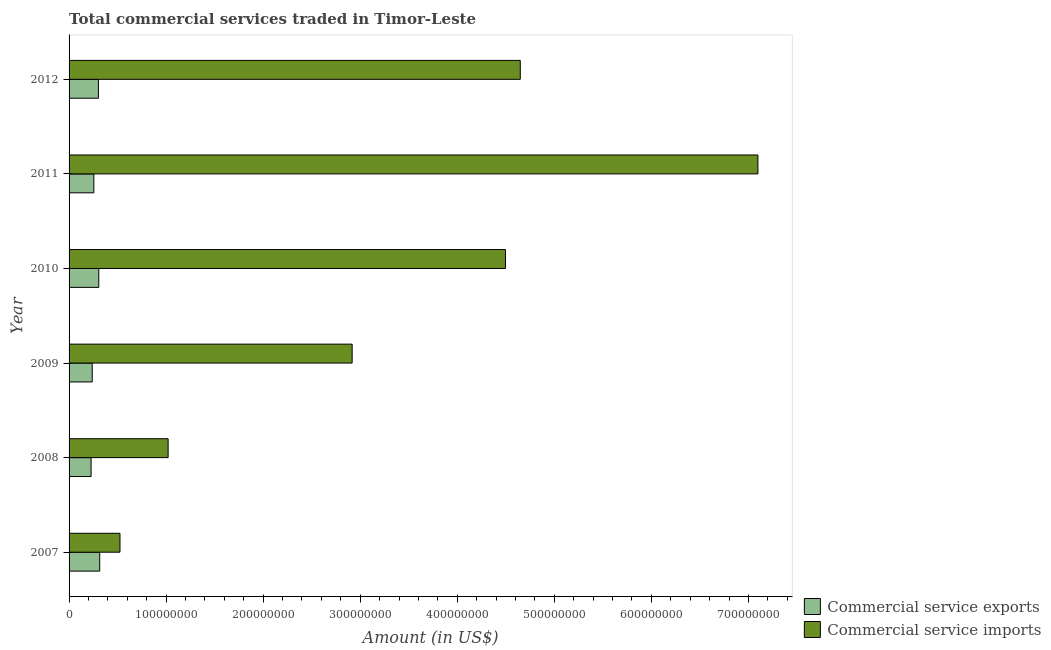How many groups of bars are there?
Ensure brevity in your answer.  6. Are the number of bars per tick equal to the number of legend labels?
Provide a short and direct response. Yes. Are the number of bars on each tick of the Y-axis equal?
Offer a very short reply. Yes. How many bars are there on the 5th tick from the bottom?
Make the answer very short. 2. What is the label of the 1st group of bars from the top?
Make the answer very short. 2012. What is the amount of commercial service imports in 2011?
Your response must be concise. 7.10e+08. Across all years, what is the maximum amount of commercial service imports?
Keep it short and to the point. 7.10e+08. Across all years, what is the minimum amount of commercial service imports?
Make the answer very short. 5.24e+07. What is the total amount of commercial service imports in the graph?
Offer a very short reply. 2.07e+09. What is the difference between the amount of commercial service imports in 2009 and that in 2011?
Provide a short and direct response. -4.18e+08. What is the difference between the amount of commercial service imports in 2009 and the amount of commercial service exports in 2012?
Your answer should be compact. 2.61e+08. What is the average amount of commercial service imports per year?
Provide a succinct answer. 3.45e+08. In the year 2007, what is the difference between the amount of commercial service exports and amount of commercial service imports?
Your answer should be compact. -2.09e+07. What is the ratio of the amount of commercial service exports in 2007 to that in 2008?
Offer a terse response. 1.39. Is the amount of commercial service imports in 2007 less than that in 2009?
Your answer should be very brief. Yes. Is the difference between the amount of commercial service exports in 2009 and 2011 greater than the difference between the amount of commercial service imports in 2009 and 2011?
Offer a terse response. Yes. What is the difference between the highest and the second highest amount of commercial service exports?
Keep it short and to the point. 9.52e+05. What is the difference between the highest and the lowest amount of commercial service imports?
Make the answer very short. 6.57e+08. What does the 2nd bar from the top in 2008 represents?
Your response must be concise. Commercial service exports. What does the 1st bar from the bottom in 2008 represents?
Keep it short and to the point. Commercial service exports. Does the graph contain any zero values?
Give a very brief answer. No. Does the graph contain grids?
Give a very brief answer. No. How are the legend labels stacked?
Keep it short and to the point. Vertical. What is the title of the graph?
Your answer should be very brief. Total commercial services traded in Timor-Leste. What is the label or title of the X-axis?
Your response must be concise. Amount (in US$). What is the Amount (in US$) of Commercial service exports in 2007?
Provide a short and direct response. 3.16e+07. What is the Amount (in US$) of Commercial service imports in 2007?
Give a very brief answer. 5.24e+07. What is the Amount (in US$) of Commercial service exports in 2008?
Offer a terse response. 2.27e+07. What is the Amount (in US$) in Commercial service imports in 2008?
Ensure brevity in your answer.  1.02e+08. What is the Amount (in US$) in Commercial service exports in 2009?
Ensure brevity in your answer.  2.38e+07. What is the Amount (in US$) in Commercial service imports in 2009?
Your response must be concise. 2.92e+08. What is the Amount (in US$) of Commercial service exports in 2010?
Provide a succinct answer. 3.06e+07. What is the Amount (in US$) of Commercial service imports in 2010?
Provide a succinct answer. 4.50e+08. What is the Amount (in US$) of Commercial service exports in 2011?
Your response must be concise. 2.55e+07. What is the Amount (in US$) in Commercial service imports in 2011?
Ensure brevity in your answer.  7.10e+08. What is the Amount (in US$) of Commercial service exports in 2012?
Make the answer very short. 3.02e+07. What is the Amount (in US$) of Commercial service imports in 2012?
Give a very brief answer. 4.65e+08. Across all years, what is the maximum Amount (in US$) in Commercial service exports?
Your response must be concise. 3.16e+07. Across all years, what is the maximum Amount (in US$) of Commercial service imports?
Your answer should be very brief. 7.10e+08. Across all years, what is the minimum Amount (in US$) of Commercial service exports?
Offer a very short reply. 2.27e+07. Across all years, what is the minimum Amount (in US$) in Commercial service imports?
Keep it short and to the point. 5.24e+07. What is the total Amount (in US$) in Commercial service exports in the graph?
Make the answer very short. 1.64e+08. What is the total Amount (in US$) of Commercial service imports in the graph?
Your answer should be compact. 2.07e+09. What is the difference between the Amount (in US$) of Commercial service exports in 2007 and that in 2008?
Provide a succinct answer. 8.88e+06. What is the difference between the Amount (in US$) of Commercial service imports in 2007 and that in 2008?
Ensure brevity in your answer.  -4.96e+07. What is the difference between the Amount (in US$) in Commercial service exports in 2007 and that in 2009?
Give a very brief answer. 7.71e+06. What is the difference between the Amount (in US$) in Commercial service imports in 2007 and that in 2009?
Provide a short and direct response. -2.39e+08. What is the difference between the Amount (in US$) of Commercial service exports in 2007 and that in 2010?
Keep it short and to the point. 9.52e+05. What is the difference between the Amount (in US$) of Commercial service imports in 2007 and that in 2010?
Offer a very short reply. -3.97e+08. What is the difference between the Amount (in US$) in Commercial service exports in 2007 and that in 2011?
Your response must be concise. 6.04e+06. What is the difference between the Amount (in US$) in Commercial service imports in 2007 and that in 2011?
Give a very brief answer. -6.57e+08. What is the difference between the Amount (in US$) of Commercial service exports in 2007 and that in 2012?
Offer a very short reply. 1.31e+06. What is the difference between the Amount (in US$) of Commercial service imports in 2007 and that in 2012?
Your answer should be very brief. -4.12e+08. What is the difference between the Amount (in US$) of Commercial service exports in 2008 and that in 2009?
Provide a succinct answer. -1.17e+06. What is the difference between the Amount (in US$) of Commercial service imports in 2008 and that in 2009?
Your answer should be very brief. -1.90e+08. What is the difference between the Amount (in US$) in Commercial service exports in 2008 and that in 2010?
Give a very brief answer. -7.93e+06. What is the difference between the Amount (in US$) of Commercial service imports in 2008 and that in 2010?
Ensure brevity in your answer.  -3.48e+08. What is the difference between the Amount (in US$) of Commercial service exports in 2008 and that in 2011?
Offer a very short reply. -2.85e+06. What is the difference between the Amount (in US$) in Commercial service imports in 2008 and that in 2011?
Ensure brevity in your answer.  -6.08e+08. What is the difference between the Amount (in US$) of Commercial service exports in 2008 and that in 2012?
Give a very brief answer. -7.57e+06. What is the difference between the Amount (in US$) of Commercial service imports in 2008 and that in 2012?
Give a very brief answer. -3.63e+08. What is the difference between the Amount (in US$) of Commercial service exports in 2009 and that in 2010?
Make the answer very short. -6.76e+06. What is the difference between the Amount (in US$) in Commercial service imports in 2009 and that in 2010?
Offer a very short reply. -1.58e+08. What is the difference between the Amount (in US$) in Commercial service exports in 2009 and that in 2011?
Make the answer very short. -1.67e+06. What is the difference between the Amount (in US$) of Commercial service imports in 2009 and that in 2011?
Give a very brief answer. -4.18e+08. What is the difference between the Amount (in US$) of Commercial service exports in 2009 and that in 2012?
Provide a short and direct response. -6.40e+06. What is the difference between the Amount (in US$) in Commercial service imports in 2009 and that in 2012?
Your answer should be compact. -1.73e+08. What is the difference between the Amount (in US$) of Commercial service exports in 2010 and that in 2011?
Provide a succinct answer. 5.08e+06. What is the difference between the Amount (in US$) in Commercial service imports in 2010 and that in 2011?
Offer a terse response. -2.60e+08. What is the difference between the Amount (in US$) in Commercial service exports in 2010 and that in 2012?
Give a very brief answer. 3.61e+05. What is the difference between the Amount (in US$) in Commercial service imports in 2010 and that in 2012?
Ensure brevity in your answer.  -1.53e+07. What is the difference between the Amount (in US$) of Commercial service exports in 2011 and that in 2012?
Provide a short and direct response. -4.72e+06. What is the difference between the Amount (in US$) in Commercial service imports in 2011 and that in 2012?
Provide a short and direct response. 2.45e+08. What is the difference between the Amount (in US$) in Commercial service exports in 2007 and the Amount (in US$) in Commercial service imports in 2008?
Offer a very short reply. -7.05e+07. What is the difference between the Amount (in US$) in Commercial service exports in 2007 and the Amount (in US$) in Commercial service imports in 2009?
Make the answer very short. -2.60e+08. What is the difference between the Amount (in US$) of Commercial service exports in 2007 and the Amount (in US$) of Commercial service imports in 2010?
Keep it short and to the point. -4.18e+08. What is the difference between the Amount (in US$) in Commercial service exports in 2007 and the Amount (in US$) in Commercial service imports in 2011?
Your answer should be compact. -6.78e+08. What is the difference between the Amount (in US$) of Commercial service exports in 2007 and the Amount (in US$) of Commercial service imports in 2012?
Provide a short and direct response. -4.33e+08. What is the difference between the Amount (in US$) in Commercial service exports in 2008 and the Amount (in US$) in Commercial service imports in 2009?
Ensure brevity in your answer.  -2.69e+08. What is the difference between the Amount (in US$) in Commercial service exports in 2008 and the Amount (in US$) in Commercial service imports in 2010?
Make the answer very short. -4.27e+08. What is the difference between the Amount (in US$) of Commercial service exports in 2008 and the Amount (in US$) of Commercial service imports in 2011?
Your answer should be compact. -6.87e+08. What is the difference between the Amount (in US$) in Commercial service exports in 2008 and the Amount (in US$) in Commercial service imports in 2012?
Keep it short and to the point. -4.42e+08. What is the difference between the Amount (in US$) in Commercial service exports in 2009 and the Amount (in US$) in Commercial service imports in 2010?
Offer a very short reply. -4.26e+08. What is the difference between the Amount (in US$) of Commercial service exports in 2009 and the Amount (in US$) of Commercial service imports in 2011?
Your answer should be compact. -6.86e+08. What is the difference between the Amount (in US$) of Commercial service exports in 2009 and the Amount (in US$) of Commercial service imports in 2012?
Make the answer very short. -4.41e+08. What is the difference between the Amount (in US$) of Commercial service exports in 2010 and the Amount (in US$) of Commercial service imports in 2011?
Your response must be concise. -6.79e+08. What is the difference between the Amount (in US$) of Commercial service exports in 2010 and the Amount (in US$) of Commercial service imports in 2012?
Offer a terse response. -4.34e+08. What is the difference between the Amount (in US$) of Commercial service exports in 2011 and the Amount (in US$) of Commercial service imports in 2012?
Give a very brief answer. -4.39e+08. What is the average Amount (in US$) of Commercial service exports per year?
Your answer should be very brief. 2.74e+07. What is the average Amount (in US$) in Commercial service imports per year?
Offer a very short reply. 3.45e+08. In the year 2007, what is the difference between the Amount (in US$) of Commercial service exports and Amount (in US$) of Commercial service imports?
Keep it short and to the point. -2.09e+07. In the year 2008, what is the difference between the Amount (in US$) of Commercial service exports and Amount (in US$) of Commercial service imports?
Your answer should be compact. -7.94e+07. In the year 2009, what is the difference between the Amount (in US$) in Commercial service exports and Amount (in US$) in Commercial service imports?
Make the answer very short. -2.68e+08. In the year 2010, what is the difference between the Amount (in US$) of Commercial service exports and Amount (in US$) of Commercial service imports?
Your answer should be very brief. -4.19e+08. In the year 2011, what is the difference between the Amount (in US$) of Commercial service exports and Amount (in US$) of Commercial service imports?
Ensure brevity in your answer.  -6.84e+08. In the year 2012, what is the difference between the Amount (in US$) of Commercial service exports and Amount (in US$) of Commercial service imports?
Your answer should be compact. -4.35e+08. What is the ratio of the Amount (in US$) of Commercial service exports in 2007 to that in 2008?
Your answer should be compact. 1.39. What is the ratio of the Amount (in US$) in Commercial service imports in 2007 to that in 2008?
Offer a very short reply. 0.51. What is the ratio of the Amount (in US$) in Commercial service exports in 2007 to that in 2009?
Provide a short and direct response. 1.32. What is the ratio of the Amount (in US$) in Commercial service imports in 2007 to that in 2009?
Your response must be concise. 0.18. What is the ratio of the Amount (in US$) of Commercial service exports in 2007 to that in 2010?
Your answer should be very brief. 1.03. What is the ratio of the Amount (in US$) in Commercial service imports in 2007 to that in 2010?
Give a very brief answer. 0.12. What is the ratio of the Amount (in US$) of Commercial service exports in 2007 to that in 2011?
Give a very brief answer. 1.24. What is the ratio of the Amount (in US$) of Commercial service imports in 2007 to that in 2011?
Ensure brevity in your answer.  0.07. What is the ratio of the Amount (in US$) in Commercial service exports in 2007 to that in 2012?
Make the answer very short. 1.04. What is the ratio of the Amount (in US$) in Commercial service imports in 2007 to that in 2012?
Offer a very short reply. 0.11. What is the ratio of the Amount (in US$) of Commercial service exports in 2008 to that in 2009?
Ensure brevity in your answer.  0.95. What is the ratio of the Amount (in US$) in Commercial service imports in 2008 to that in 2009?
Offer a terse response. 0.35. What is the ratio of the Amount (in US$) of Commercial service exports in 2008 to that in 2010?
Make the answer very short. 0.74. What is the ratio of the Amount (in US$) in Commercial service imports in 2008 to that in 2010?
Ensure brevity in your answer.  0.23. What is the ratio of the Amount (in US$) in Commercial service exports in 2008 to that in 2011?
Offer a terse response. 0.89. What is the ratio of the Amount (in US$) of Commercial service imports in 2008 to that in 2011?
Your answer should be compact. 0.14. What is the ratio of the Amount (in US$) of Commercial service exports in 2008 to that in 2012?
Your answer should be compact. 0.75. What is the ratio of the Amount (in US$) in Commercial service imports in 2008 to that in 2012?
Provide a succinct answer. 0.22. What is the ratio of the Amount (in US$) in Commercial service exports in 2009 to that in 2010?
Give a very brief answer. 0.78. What is the ratio of the Amount (in US$) in Commercial service imports in 2009 to that in 2010?
Provide a short and direct response. 0.65. What is the ratio of the Amount (in US$) of Commercial service exports in 2009 to that in 2011?
Make the answer very short. 0.93. What is the ratio of the Amount (in US$) of Commercial service imports in 2009 to that in 2011?
Ensure brevity in your answer.  0.41. What is the ratio of the Amount (in US$) in Commercial service exports in 2009 to that in 2012?
Your response must be concise. 0.79. What is the ratio of the Amount (in US$) of Commercial service imports in 2009 to that in 2012?
Your response must be concise. 0.63. What is the ratio of the Amount (in US$) of Commercial service exports in 2010 to that in 2011?
Your response must be concise. 1.2. What is the ratio of the Amount (in US$) in Commercial service imports in 2010 to that in 2011?
Offer a very short reply. 0.63. What is the ratio of the Amount (in US$) in Commercial service exports in 2010 to that in 2012?
Offer a very short reply. 1.01. What is the ratio of the Amount (in US$) in Commercial service imports in 2010 to that in 2012?
Offer a terse response. 0.97. What is the ratio of the Amount (in US$) of Commercial service exports in 2011 to that in 2012?
Your answer should be compact. 0.84. What is the ratio of the Amount (in US$) of Commercial service imports in 2011 to that in 2012?
Provide a succinct answer. 1.53. What is the difference between the highest and the second highest Amount (in US$) of Commercial service exports?
Provide a short and direct response. 9.52e+05. What is the difference between the highest and the second highest Amount (in US$) of Commercial service imports?
Provide a succinct answer. 2.45e+08. What is the difference between the highest and the lowest Amount (in US$) in Commercial service exports?
Provide a succinct answer. 8.88e+06. What is the difference between the highest and the lowest Amount (in US$) in Commercial service imports?
Offer a terse response. 6.57e+08. 